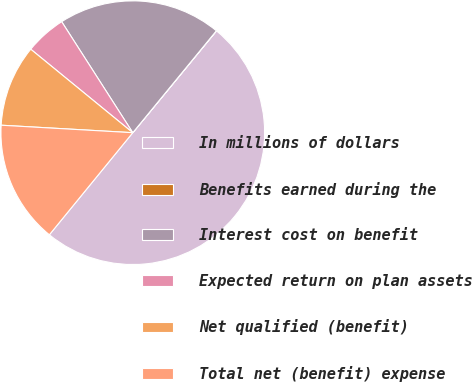Convert chart to OTSL. <chart><loc_0><loc_0><loc_500><loc_500><pie_chart><fcel>In millions of dollars<fcel>Benefits earned during the<fcel>Interest cost on benefit<fcel>Expected return on plan assets<fcel>Net qualified (benefit)<fcel>Total net (benefit) expense<nl><fcel>49.95%<fcel>0.02%<fcel>20.0%<fcel>5.02%<fcel>10.01%<fcel>15.0%<nl></chart> 